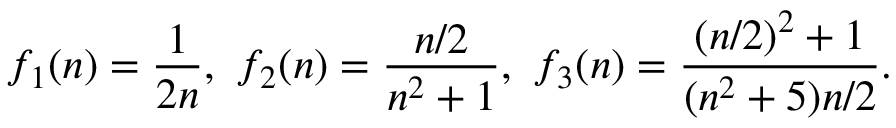Convert formula to latex. <formula><loc_0><loc_0><loc_500><loc_500>f _ { 1 } ( n ) = { \frac { 1 } { 2 n } } , \ f _ { 2 } ( n ) = { \frac { n / 2 } { n ^ { 2 } + 1 } } , \ f _ { 3 } ( n ) = { \frac { ( n / 2 ) ^ { 2 } + 1 } { ( n ^ { 2 } + 5 ) n / 2 } } .</formula> 